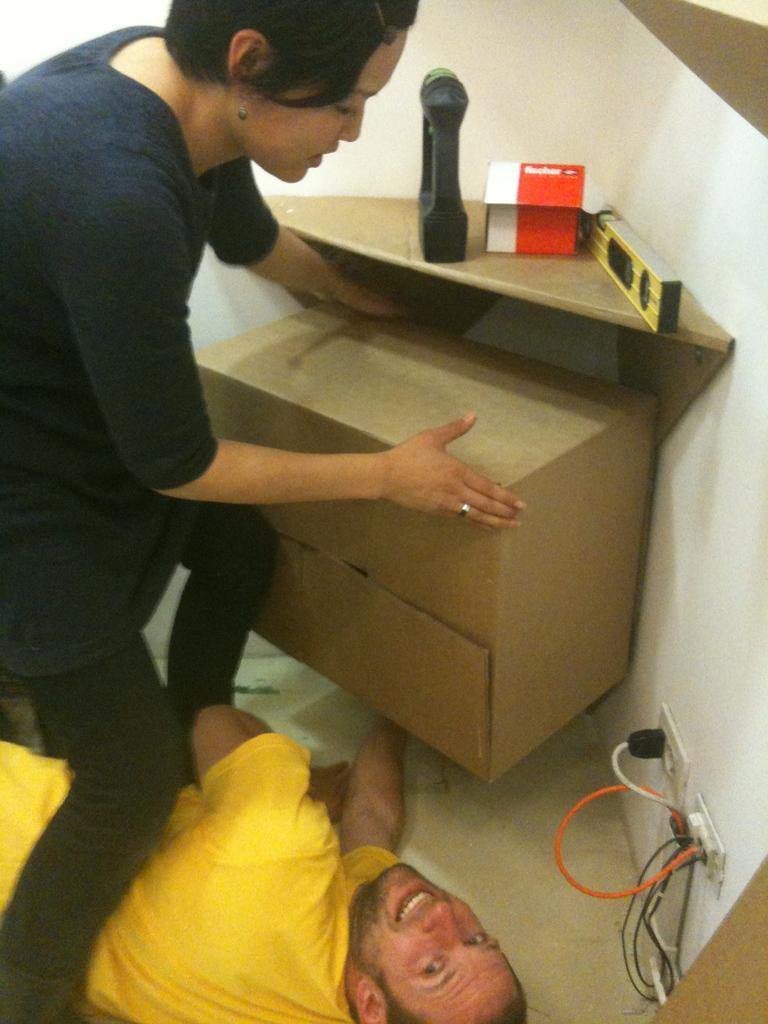Can you describe this image briefly? In this image we can see a woman is standing and a man is lying on the floor. Woman is wearing dark blue color t-shirt with black jeans and man is wearing yellow color t-shirt and they are arranging some wooden thing under the wooden cupboard. Right side of the image switch board and wires are there. 